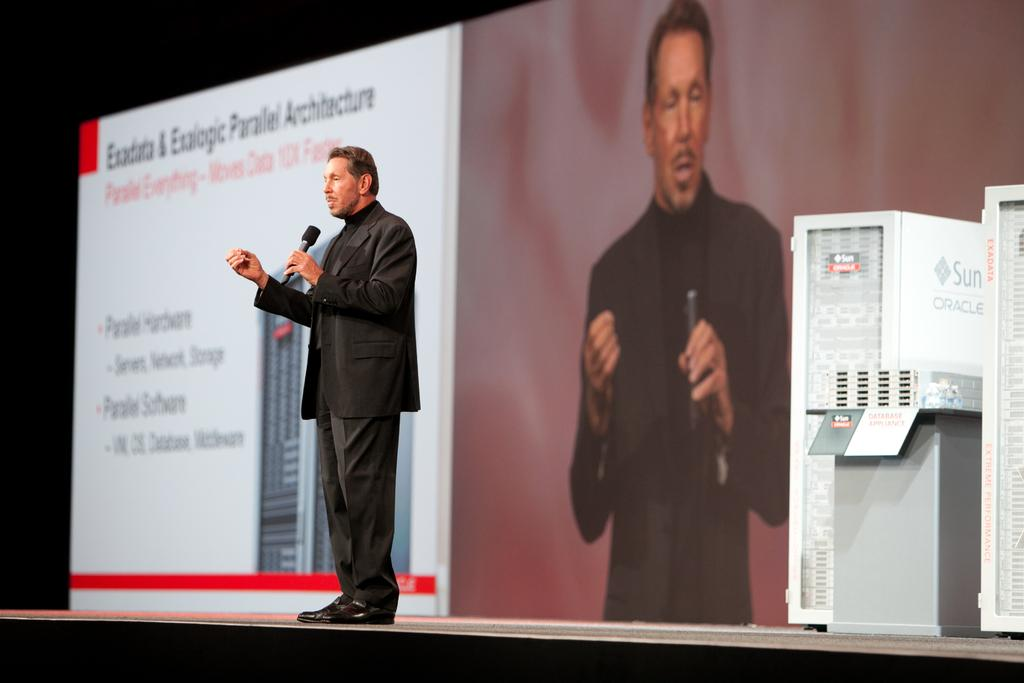What is the person on the stage doing? The person is standing on the stage and holding a microphone. What might the person be using the microphone for? The person might be using the microphone for speaking or singing. What else can be seen on the stage? There are objects on the stage. What is present in the background of the image? There is a screen in the background. How many giants are visible on the stage in the image? There are no giants visible on the stage in the image. What type of expansion is being shown on the screen in the background? There is no indication of any expansion on the screen in the background; it is not mentioned in the provided facts. 